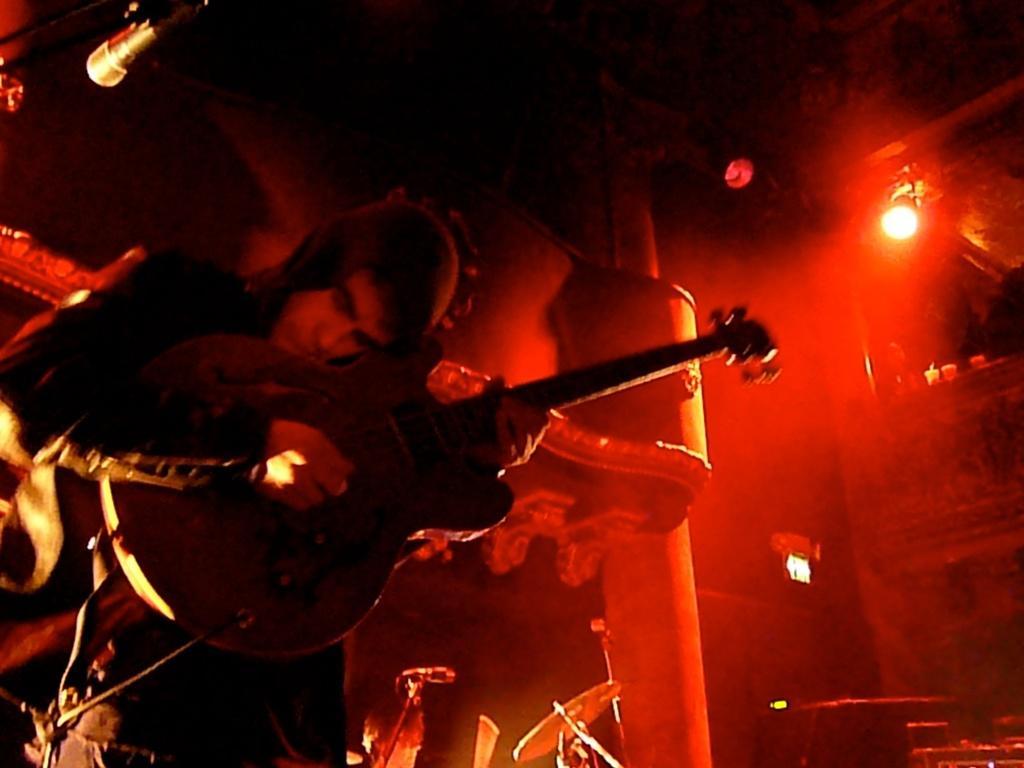Could you give a brief overview of what you see in this image? In this image there is a person wearing black color jacket playing guitar and at the background of the image there is red color light. 